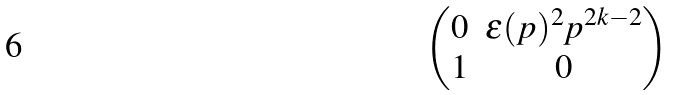Convert formula to latex. <formula><loc_0><loc_0><loc_500><loc_500>\begin{pmatrix} 0 & \epsilon ( p ) ^ { 2 } p ^ { 2 k - 2 } \\ 1 & 0 \end{pmatrix}</formula> 